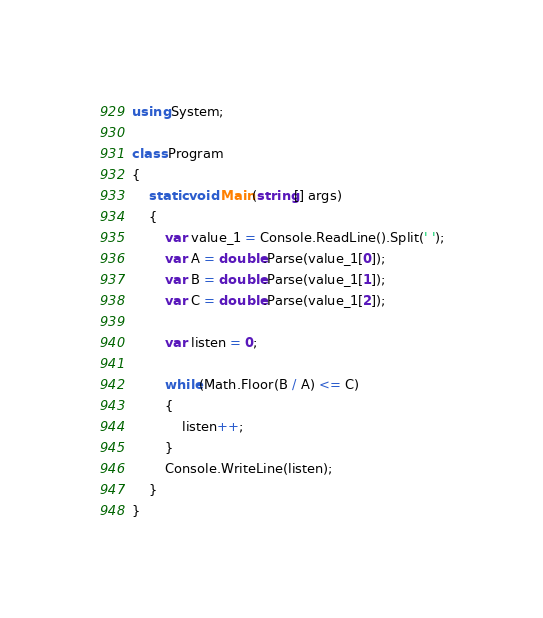Convert code to text. <code><loc_0><loc_0><loc_500><loc_500><_C#_>using System;

class Program
{
	static void Main(string[] args)
	{
		var value_1 = Console.ReadLine().Split(' ');
		var A = double.Parse(value_1[0]);
		var B = double.Parse(value_1[1]);
		var C = double.Parse(value_1[2]);

		var listen = 0;
		
		while(Math.Floor(B / A) <= C)
		{
			listen++;
		}
		Console.WriteLine(listen);
	}
}</code> 